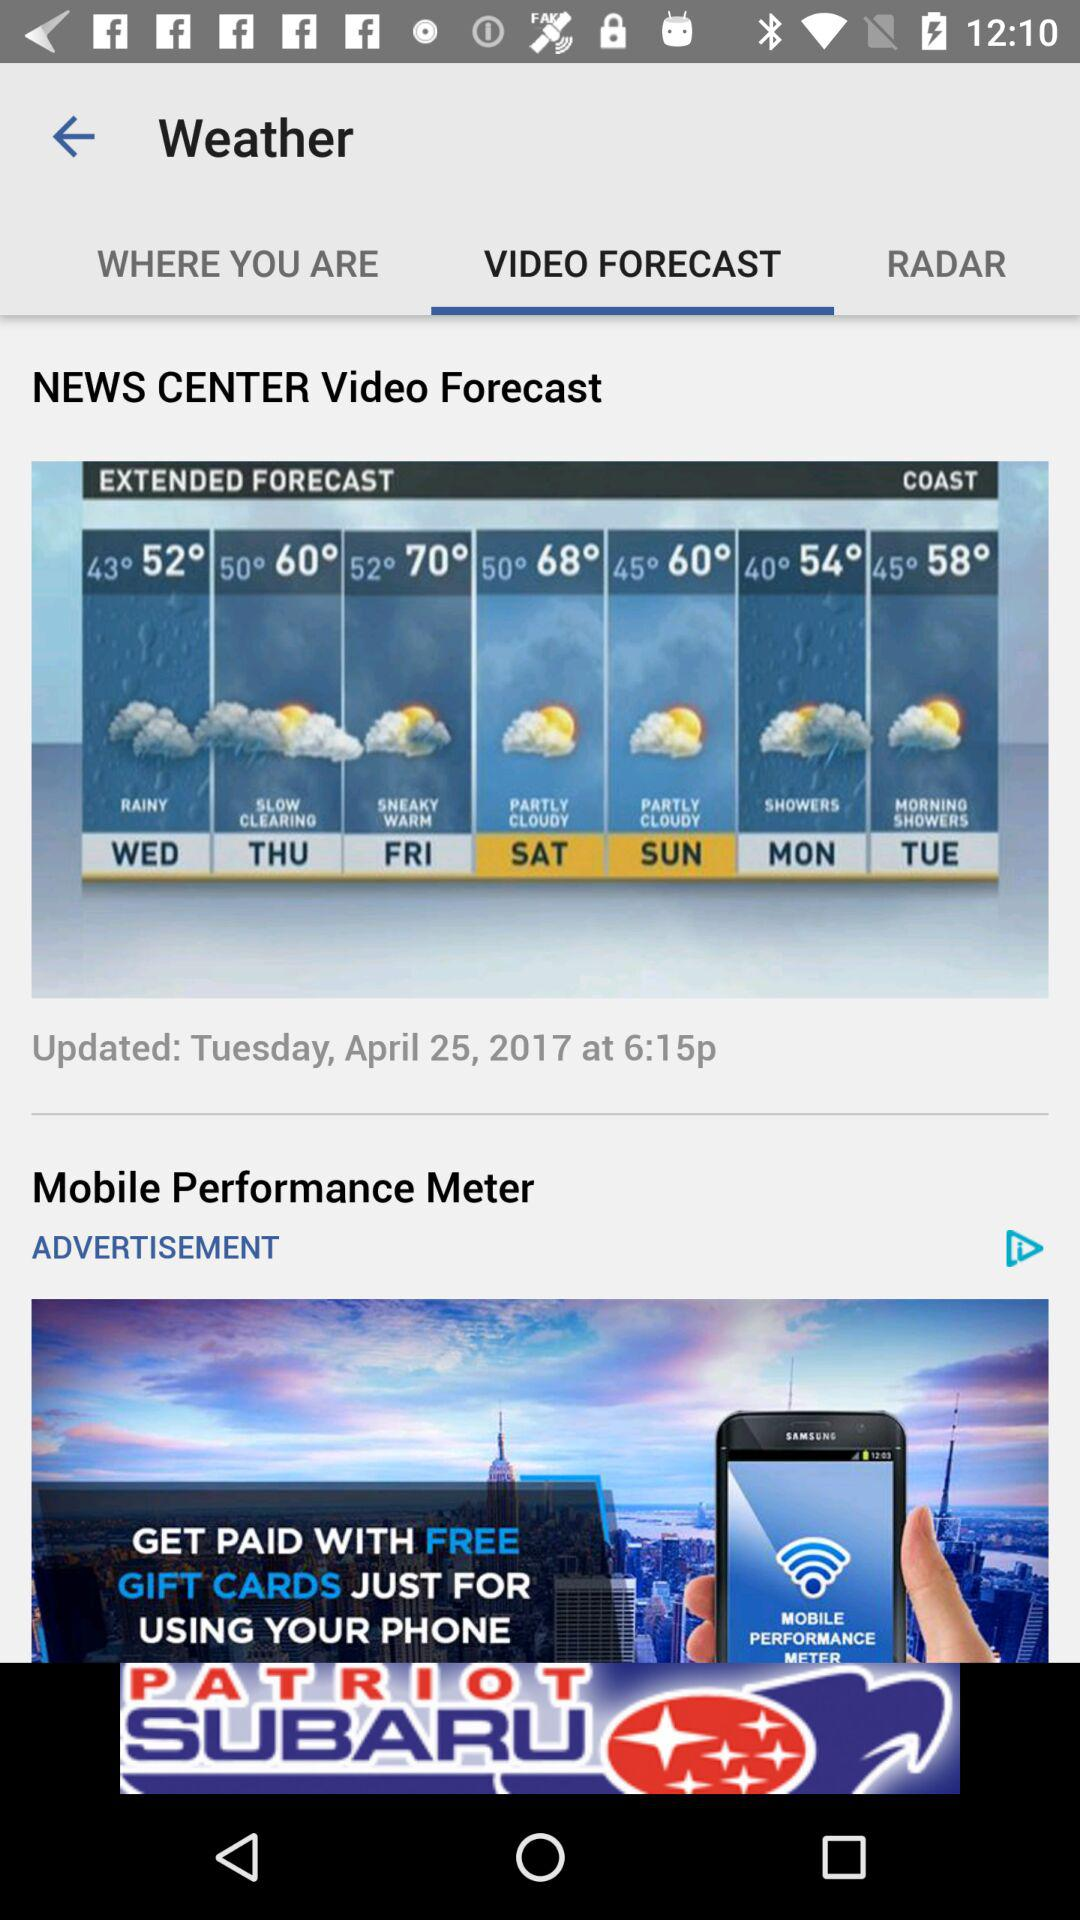What is the weather forecast for Monday? The weather forecast for Monday shows showers. 